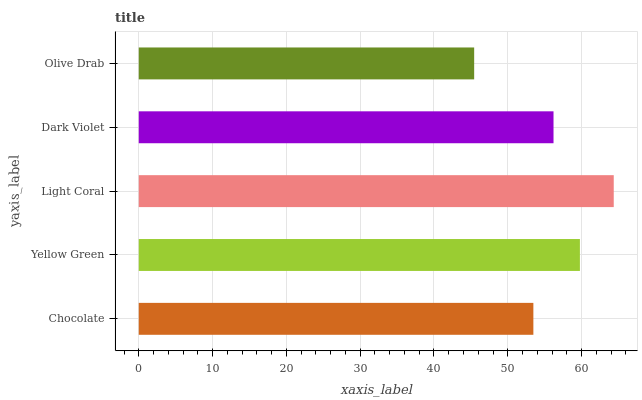Is Olive Drab the minimum?
Answer yes or no. Yes. Is Light Coral the maximum?
Answer yes or no. Yes. Is Yellow Green the minimum?
Answer yes or no. No. Is Yellow Green the maximum?
Answer yes or no. No. Is Yellow Green greater than Chocolate?
Answer yes or no. Yes. Is Chocolate less than Yellow Green?
Answer yes or no. Yes. Is Chocolate greater than Yellow Green?
Answer yes or no. No. Is Yellow Green less than Chocolate?
Answer yes or no. No. Is Dark Violet the high median?
Answer yes or no. Yes. Is Dark Violet the low median?
Answer yes or no. Yes. Is Yellow Green the high median?
Answer yes or no. No. Is Light Coral the low median?
Answer yes or no. No. 